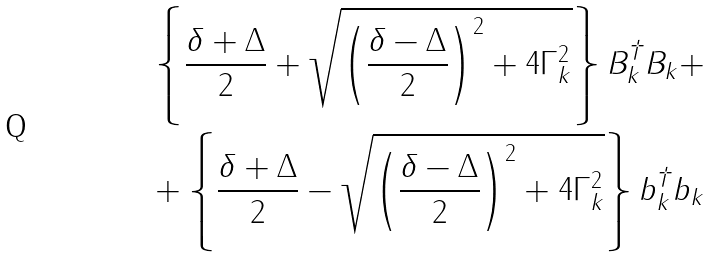Convert formula to latex. <formula><loc_0><loc_0><loc_500><loc_500>\left \{ { \frac { \delta + \Delta } { 2 } + \sqrt { \left ( { \frac { \delta - \Delta } { 2 } } \right ) ^ { 2 } + 4 \Gamma _ { k } ^ { 2 } } } \right \} B _ { k } ^ { \dag } B _ { k } + \\ + \left \{ { \frac { \delta + \Delta } { 2 } - \sqrt { \left ( { \frac { \delta - \Delta } { 2 } } \right ) ^ { 2 } + 4 \Gamma _ { k } ^ { 2 } } } \right \} b _ { k } ^ { \dag } b _ { k }</formula> 